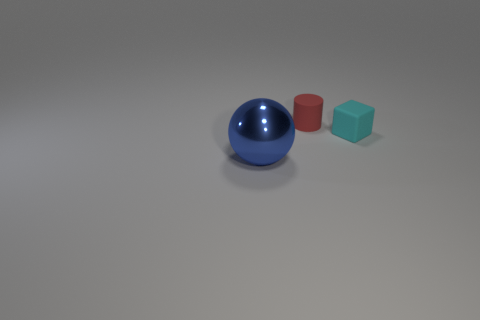There is a tiny thing that is behind the tiny cyan rubber block; is its color the same as the tiny rubber cube?
Keep it short and to the point. No. What number of large balls are made of the same material as the small cyan object?
Your answer should be compact. 0. There is a thing that is in front of the rubber thing to the right of the small red object; are there any large blue metal balls in front of it?
Keep it short and to the point. No. The small cyan rubber object is what shape?
Make the answer very short. Cube. Are the small object on the left side of the cyan cube and the cyan object that is in front of the tiny red matte cylinder made of the same material?
Your answer should be very brief. Yes. There is a object that is both to the right of the large blue object and on the left side of the small block; what shape is it?
Your answer should be very brief. Cylinder. What color is the thing that is both in front of the small cylinder and behind the big blue metal sphere?
Offer a very short reply. Cyan. Is the number of blue balls that are to the left of the cyan rubber block greater than the number of metallic things on the left side of the big object?
Give a very brief answer. Yes. What is the color of the thing in front of the small cyan matte object?
Provide a short and direct response. Blue. Does the matte thing that is to the left of the small cyan object have the same shape as the metallic thing in front of the cyan rubber thing?
Make the answer very short. No. 